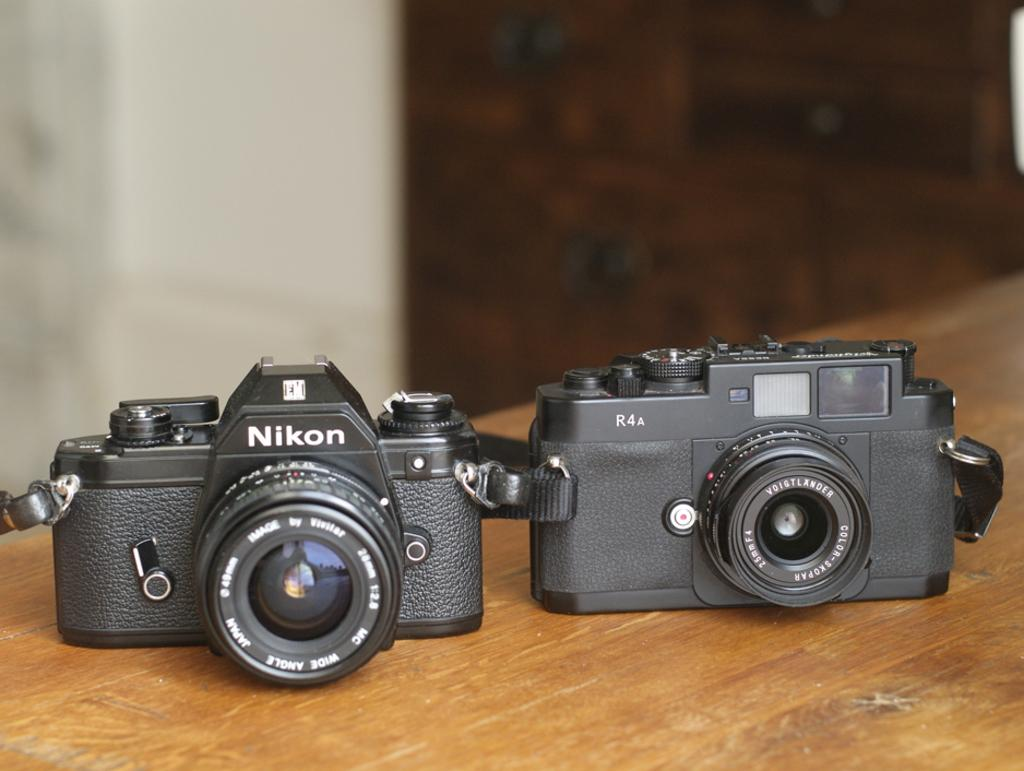What is the main object in the image? There is a table in the image. What can be seen on the table? There are two cameras on the table. Can you describe the background of the image? The background of the image is blurry. How many houses are visible in the image? There are no houses visible in the image; it only features a table with two cameras and a blurry background. 